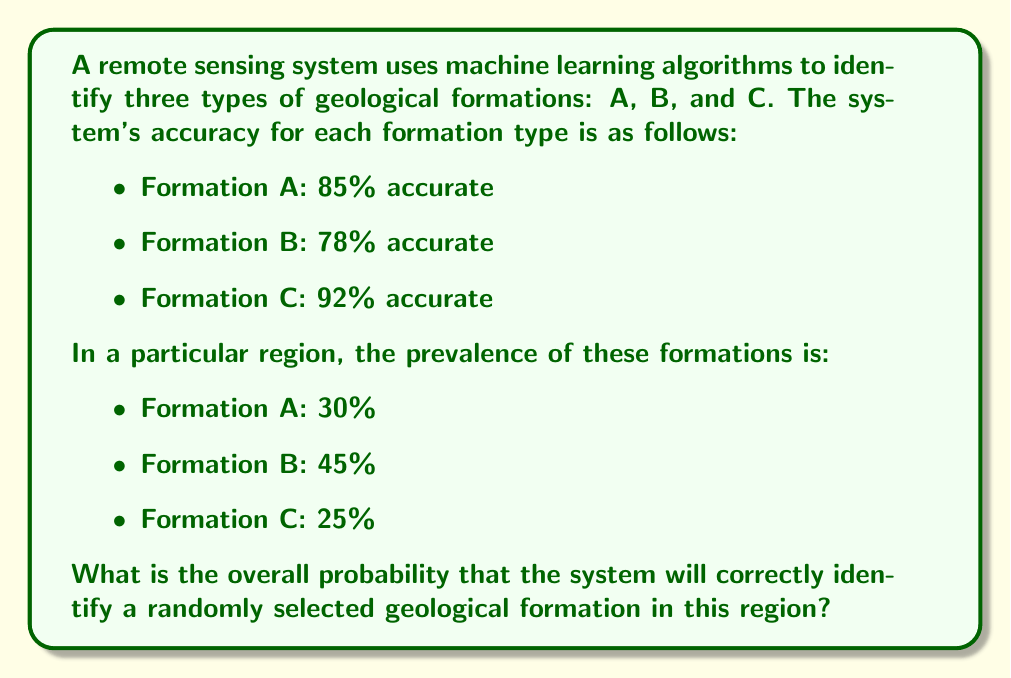Could you help me with this problem? To solve this problem, we need to use the law of total probability. Let's break it down step by step:

1) Let's define our events:
   - $C$: The system correctly identifies the formation
   - $A$, $B$, $C$: The formation is of type A, B, or C respectively

2) We're given the following probabilities:
   - $P(C|A) = 0.85$ (accuracy for Formation A)
   - $P(C|B) = 0.78$ (accuracy for Formation B)
   - $P(C|C) = 0.92$ (accuracy for Formation C)
   - $P(A) = 0.30$ (prevalence of Formation A)
   - $P(B) = 0.45$ (prevalence of Formation B)
   - $P(C) = 0.25$ (prevalence of Formation C)

3) The law of total probability states:

   $$P(C) = P(C|A)P(A) + P(C|B)P(B) + P(C|C)P(C)$$

4) Let's substitute our values:

   $$P(C) = (0.85 * 0.30) + (0.78 * 0.45) + (0.92 * 0.25)$$

5) Now let's calculate:
   
   $$P(C) = 0.255 + 0.351 + 0.230 = 0.836$$

Therefore, the overall probability of correctly identifying a randomly selected geological formation in this region is 0.836 or 83.6%.
Answer: 0.836 or 83.6% 